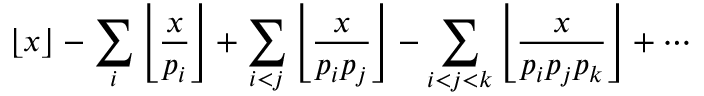<formula> <loc_0><loc_0><loc_500><loc_500>\lfloor x \rfloor - \sum _ { i } \left \lfloor { \frac { x } { p _ { i } } } \right \rfloor + \sum _ { i < j } \left \lfloor { \frac { x } { p _ { i } p _ { j } } } \right \rfloor - \sum _ { i < j < k } \left \lfloor { \frac { x } { p _ { i } p _ { j } p _ { k } } } \right \rfloor + \cdots</formula> 